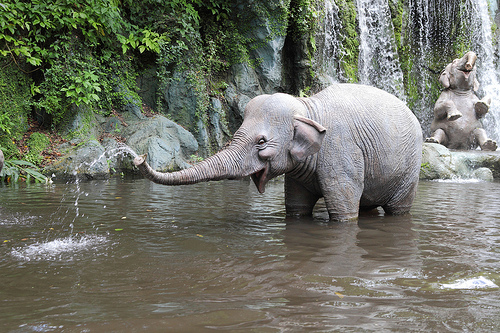Is there a surfboard or a can in the photograph? The image does not contain a surfboard or a can. 